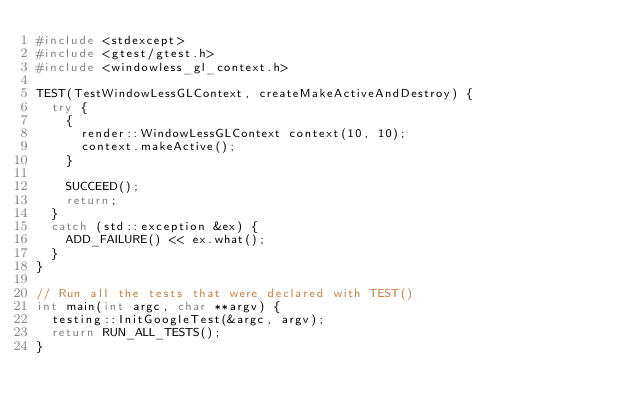<code> <loc_0><loc_0><loc_500><loc_500><_C++_>#include <stdexcept>
#include <gtest/gtest.h>
#include <windowless_gl_context.h>

TEST(TestWindowLessGLContext, createMakeActiveAndDestroy) {
  try {
    {
      render::WindowLessGLContext context(10, 10);
      context.makeActive();
    }

    SUCCEED();
    return;
  }
  catch (std::exception &ex) {
    ADD_FAILURE() << ex.what();
  }
}

// Run all the tests that were declared with TEST()
int main(int argc, char **argv) {
  testing::InitGoogleTest(&argc, argv);
  return RUN_ALL_TESTS();
}
</code> 